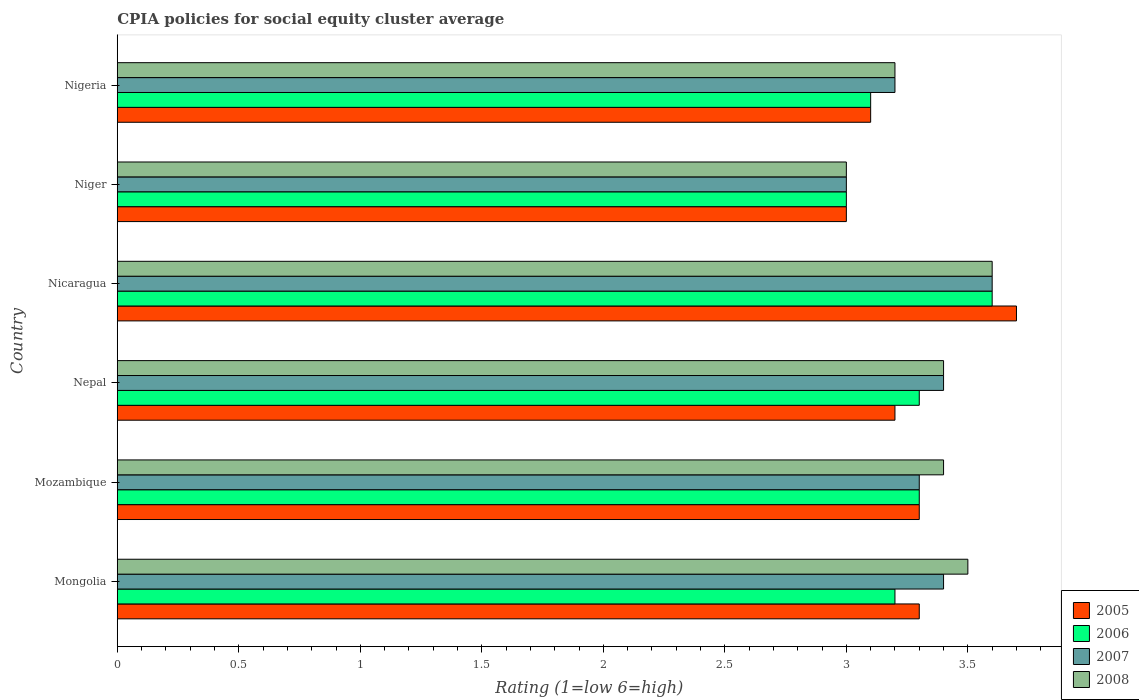How many different coloured bars are there?
Your answer should be compact. 4. Are the number of bars on each tick of the Y-axis equal?
Your response must be concise. Yes. How many bars are there on the 5th tick from the top?
Provide a succinct answer. 4. How many bars are there on the 6th tick from the bottom?
Ensure brevity in your answer.  4. What is the label of the 5th group of bars from the top?
Your answer should be compact. Mozambique. In which country was the CPIA rating in 2006 maximum?
Your answer should be very brief. Nicaragua. In which country was the CPIA rating in 2007 minimum?
Make the answer very short. Niger. What is the difference between the CPIA rating in 2008 in Mongolia and that in Nigeria?
Make the answer very short. 0.3. What is the difference between the CPIA rating in 2005 in Niger and the CPIA rating in 2006 in Nicaragua?
Your answer should be compact. -0.6. What is the average CPIA rating in 2005 per country?
Make the answer very short. 3.27. What is the difference between the CPIA rating in 2005 and CPIA rating in 2007 in Nigeria?
Give a very brief answer. -0.1. Is the CPIA rating in 2007 in Nepal less than that in Niger?
Make the answer very short. No. What is the difference between the highest and the second highest CPIA rating in 2005?
Offer a terse response. 0.4. What is the difference between the highest and the lowest CPIA rating in 2006?
Your answer should be very brief. 0.6. In how many countries, is the CPIA rating in 2006 greater than the average CPIA rating in 2006 taken over all countries?
Give a very brief answer. 3. Is the sum of the CPIA rating in 2006 in Mongolia and Nepal greater than the maximum CPIA rating in 2005 across all countries?
Make the answer very short. Yes. Is it the case that in every country, the sum of the CPIA rating in 2006 and CPIA rating in 2007 is greater than the sum of CPIA rating in 2005 and CPIA rating in 2008?
Your answer should be very brief. No. What is the difference between two consecutive major ticks on the X-axis?
Make the answer very short. 0.5. Are the values on the major ticks of X-axis written in scientific E-notation?
Give a very brief answer. No. What is the title of the graph?
Keep it short and to the point. CPIA policies for social equity cluster average. Does "1961" appear as one of the legend labels in the graph?
Give a very brief answer. No. What is the label or title of the X-axis?
Offer a terse response. Rating (1=low 6=high). What is the Rating (1=low 6=high) of 2006 in Mongolia?
Ensure brevity in your answer.  3.2. What is the Rating (1=low 6=high) in 2008 in Mongolia?
Offer a very short reply. 3.5. What is the Rating (1=low 6=high) of 2005 in Mozambique?
Provide a short and direct response. 3.3. What is the Rating (1=low 6=high) of 2007 in Nepal?
Offer a terse response. 3.4. What is the Rating (1=low 6=high) in 2005 in Nicaragua?
Give a very brief answer. 3.7. What is the Rating (1=low 6=high) in 2007 in Niger?
Provide a short and direct response. 3. What is the Rating (1=low 6=high) in 2005 in Nigeria?
Provide a succinct answer. 3.1. What is the Rating (1=low 6=high) of 2006 in Nigeria?
Provide a short and direct response. 3.1. What is the Rating (1=low 6=high) in 2007 in Nigeria?
Provide a succinct answer. 3.2. Across all countries, what is the maximum Rating (1=low 6=high) in 2006?
Give a very brief answer. 3.6. Across all countries, what is the minimum Rating (1=low 6=high) in 2008?
Ensure brevity in your answer.  3. What is the total Rating (1=low 6=high) of 2005 in the graph?
Your response must be concise. 19.6. What is the total Rating (1=low 6=high) of 2008 in the graph?
Your response must be concise. 20.1. What is the difference between the Rating (1=low 6=high) in 2005 in Mongolia and that in Mozambique?
Provide a succinct answer. 0. What is the difference between the Rating (1=low 6=high) of 2006 in Mongolia and that in Mozambique?
Your answer should be very brief. -0.1. What is the difference between the Rating (1=low 6=high) in 2007 in Mongolia and that in Mozambique?
Offer a terse response. 0.1. What is the difference between the Rating (1=low 6=high) in 2008 in Mongolia and that in Mozambique?
Provide a succinct answer. 0.1. What is the difference between the Rating (1=low 6=high) in 2005 in Mongolia and that in Nepal?
Give a very brief answer. 0.1. What is the difference between the Rating (1=low 6=high) in 2008 in Mongolia and that in Nepal?
Give a very brief answer. 0.1. What is the difference between the Rating (1=low 6=high) of 2006 in Mongolia and that in Nicaragua?
Keep it short and to the point. -0.4. What is the difference between the Rating (1=low 6=high) in 2005 in Mongolia and that in Niger?
Provide a short and direct response. 0.3. What is the difference between the Rating (1=low 6=high) in 2007 in Mongolia and that in Niger?
Make the answer very short. 0.4. What is the difference between the Rating (1=low 6=high) in 2008 in Mongolia and that in Nigeria?
Offer a terse response. 0.3. What is the difference between the Rating (1=low 6=high) of 2005 in Mozambique and that in Nepal?
Make the answer very short. 0.1. What is the difference between the Rating (1=low 6=high) of 2005 in Mozambique and that in Nicaragua?
Offer a very short reply. -0.4. What is the difference between the Rating (1=low 6=high) in 2007 in Mozambique and that in Nicaragua?
Provide a short and direct response. -0.3. What is the difference between the Rating (1=low 6=high) of 2005 in Mozambique and that in Niger?
Your answer should be compact. 0.3. What is the difference between the Rating (1=low 6=high) of 2006 in Mozambique and that in Niger?
Your answer should be compact. 0.3. What is the difference between the Rating (1=low 6=high) in 2008 in Mozambique and that in Niger?
Your answer should be compact. 0.4. What is the difference between the Rating (1=low 6=high) in 2006 in Mozambique and that in Nigeria?
Provide a short and direct response. 0.2. What is the difference between the Rating (1=low 6=high) of 2008 in Mozambique and that in Nigeria?
Your answer should be very brief. 0.2. What is the difference between the Rating (1=low 6=high) of 2007 in Nepal and that in Nicaragua?
Offer a very short reply. -0.2. What is the difference between the Rating (1=low 6=high) in 2008 in Nepal and that in Nicaragua?
Give a very brief answer. -0.2. What is the difference between the Rating (1=low 6=high) of 2005 in Nepal and that in Niger?
Ensure brevity in your answer.  0.2. What is the difference between the Rating (1=low 6=high) in 2007 in Nepal and that in Niger?
Provide a short and direct response. 0.4. What is the difference between the Rating (1=low 6=high) of 2005 in Nepal and that in Nigeria?
Provide a succinct answer. 0.1. What is the difference between the Rating (1=low 6=high) of 2006 in Nepal and that in Nigeria?
Your answer should be compact. 0.2. What is the difference between the Rating (1=low 6=high) in 2007 in Nepal and that in Nigeria?
Your answer should be very brief. 0.2. What is the difference between the Rating (1=low 6=high) of 2008 in Nepal and that in Nigeria?
Offer a terse response. 0.2. What is the difference between the Rating (1=low 6=high) of 2005 in Nicaragua and that in Niger?
Ensure brevity in your answer.  0.7. What is the difference between the Rating (1=low 6=high) in 2007 in Nicaragua and that in Niger?
Make the answer very short. 0.6. What is the difference between the Rating (1=low 6=high) of 2008 in Nicaragua and that in Niger?
Give a very brief answer. 0.6. What is the difference between the Rating (1=low 6=high) of 2005 in Mongolia and the Rating (1=low 6=high) of 2007 in Mozambique?
Offer a terse response. 0. What is the difference between the Rating (1=low 6=high) of 2007 in Mongolia and the Rating (1=low 6=high) of 2008 in Mozambique?
Give a very brief answer. 0. What is the difference between the Rating (1=low 6=high) of 2005 in Mongolia and the Rating (1=low 6=high) of 2007 in Nepal?
Your answer should be compact. -0.1. What is the difference between the Rating (1=low 6=high) of 2005 in Mongolia and the Rating (1=low 6=high) of 2008 in Nepal?
Your answer should be compact. -0.1. What is the difference between the Rating (1=low 6=high) in 2006 in Mongolia and the Rating (1=low 6=high) in 2007 in Nepal?
Ensure brevity in your answer.  -0.2. What is the difference between the Rating (1=low 6=high) of 2006 in Mongolia and the Rating (1=low 6=high) of 2008 in Nepal?
Offer a very short reply. -0.2. What is the difference between the Rating (1=low 6=high) of 2006 in Mongolia and the Rating (1=low 6=high) of 2007 in Nicaragua?
Make the answer very short. -0.4. What is the difference between the Rating (1=low 6=high) of 2006 in Mongolia and the Rating (1=low 6=high) of 2008 in Nicaragua?
Your answer should be very brief. -0.4. What is the difference between the Rating (1=low 6=high) of 2005 in Mongolia and the Rating (1=low 6=high) of 2008 in Niger?
Your answer should be compact. 0.3. What is the difference between the Rating (1=low 6=high) in 2006 in Mongolia and the Rating (1=low 6=high) in 2007 in Niger?
Ensure brevity in your answer.  0.2. What is the difference between the Rating (1=low 6=high) in 2007 in Mongolia and the Rating (1=low 6=high) in 2008 in Niger?
Your answer should be very brief. 0.4. What is the difference between the Rating (1=low 6=high) in 2005 in Mongolia and the Rating (1=low 6=high) in 2006 in Nigeria?
Make the answer very short. 0.2. What is the difference between the Rating (1=low 6=high) of 2006 in Mongolia and the Rating (1=low 6=high) of 2008 in Nigeria?
Provide a short and direct response. 0. What is the difference between the Rating (1=low 6=high) in 2007 in Mongolia and the Rating (1=low 6=high) in 2008 in Nigeria?
Ensure brevity in your answer.  0.2. What is the difference between the Rating (1=low 6=high) of 2005 in Mozambique and the Rating (1=low 6=high) of 2006 in Nepal?
Give a very brief answer. 0. What is the difference between the Rating (1=low 6=high) of 2005 in Mozambique and the Rating (1=low 6=high) of 2007 in Nepal?
Ensure brevity in your answer.  -0.1. What is the difference between the Rating (1=low 6=high) in 2007 in Mozambique and the Rating (1=low 6=high) in 2008 in Nepal?
Provide a short and direct response. -0.1. What is the difference between the Rating (1=low 6=high) in 2005 in Mozambique and the Rating (1=low 6=high) in 2007 in Nicaragua?
Give a very brief answer. -0.3. What is the difference between the Rating (1=low 6=high) in 2007 in Mozambique and the Rating (1=low 6=high) in 2008 in Nicaragua?
Your answer should be very brief. -0.3. What is the difference between the Rating (1=low 6=high) of 2005 in Mozambique and the Rating (1=low 6=high) of 2006 in Niger?
Offer a very short reply. 0.3. What is the difference between the Rating (1=low 6=high) of 2005 in Mozambique and the Rating (1=low 6=high) of 2007 in Niger?
Make the answer very short. 0.3. What is the difference between the Rating (1=low 6=high) of 2006 in Mozambique and the Rating (1=low 6=high) of 2008 in Niger?
Provide a succinct answer. 0.3. What is the difference between the Rating (1=low 6=high) of 2007 in Mozambique and the Rating (1=low 6=high) of 2008 in Niger?
Ensure brevity in your answer.  0.3. What is the difference between the Rating (1=low 6=high) of 2005 in Mozambique and the Rating (1=low 6=high) of 2006 in Nigeria?
Make the answer very short. 0.2. What is the difference between the Rating (1=low 6=high) of 2005 in Mozambique and the Rating (1=low 6=high) of 2007 in Nigeria?
Make the answer very short. 0.1. What is the difference between the Rating (1=low 6=high) in 2006 in Mozambique and the Rating (1=low 6=high) in 2007 in Nigeria?
Give a very brief answer. 0.1. What is the difference between the Rating (1=low 6=high) in 2006 in Nepal and the Rating (1=low 6=high) in 2007 in Nicaragua?
Your answer should be very brief. -0.3. What is the difference between the Rating (1=low 6=high) in 2006 in Nepal and the Rating (1=low 6=high) in 2008 in Nicaragua?
Offer a very short reply. -0.3. What is the difference between the Rating (1=low 6=high) of 2005 in Nepal and the Rating (1=low 6=high) of 2006 in Niger?
Ensure brevity in your answer.  0.2. What is the difference between the Rating (1=low 6=high) in 2005 in Nepal and the Rating (1=low 6=high) in 2008 in Niger?
Your response must be concise. 0.2. What is the difference between the Rating (1=low 6=high) in 2006 in Nepal and the Rating (1=low 6=high) in 2007 in Niger?
Your answer should be very brief. 0.3. What is the difference between the Rating (1=low 6=high) in 2005 in Nepal and the Rating (1=low 6=high) in 2007 in Nigeria?
Your answer should be compact. 0. What is the difference between the Rating (1=low 6=high) in 2006 in Nepal and the Rating (1=low 6=high) in 2007 in Nigeria?
Your response must be concise. 0.1. What is the difference between the Rating (1=low 6=high) of 2007 in Nepal and the Rating (1=low 6=high) of 2008 in Nigeria?
Offer a terse response. 0.2. What is the difference between the Rating (1=low 6=high) in 2005 in Nicaragua and the Rating (1=low 6=high) in 2008 in Niger?
Offer a terse response. 0.7. What is the difference between the Rating (1=low 6=high) in 2006 in Nicaragua and the Rating (1=low 6=high) in 2007 in Niger?
Keep it short and to the point. 0.6. What is the difference between the Rating (1=low 6=high) in 2005 in Nicaragua and the Rating (1=low 6=high) in 2008 in Nigeria?
Provide a succinct answer. 0.5. What is the difference between the Rating (1=low 6=high) in 2006 in Nicaragua and the Rating (1=low 6=high) in 2007 in Nigeria?
Provide a short and direct response. 0.4. What is the difference between the Rating (1=low 6=high) in 2007 in Nicaragua and the Rating (1=low 6=high) in 2008 in Nigeria?
Ensure brevity in your answer.  0.4. What is the difference between the Rating (1=low 6=high) in 2005 in Niger and the Rating (1=low 6=high) in 2006 in Nigeria?
Provide a succinct answer. -0.1. What is the difference between the Rating (1=low 6=high) in 2006 in Niger and the Rating (1=low 6=high) in 2007 in Nigeria?
Provide a succinct answer. -0.2. What is the difference between the Rating (1=low 6=high) of 2006 in Niger and the Rating (1=low 6=high) of 2008 in Nigeria?
Your answer should be very brief. -0.2. What is the average Rating (1=low 6=high) of 2005 per country?
Offer a very short reply. 3.27. What is the average Rating (1=low 6=high) of 2006 per country?
Your answer should be very brief. 3.25. What is the average Rating (1=low 6=high) in 2007 per country?
Keep it short and to the point. 3.32. What is the average Rating (1=low 6=high) of 2008 per country?
Make the answer very short. 3.35. What is the difference between the Rating (1=low 6=high) in 2005 and Rating (1=low 6=high) in 2007 in Mongolia?
Provide a short and direct response. -0.1. What is the difference between the Rating (1=low 6=high) of 2005 and Rating (1=low 6=high) of 2008 in Mongolia?
Offer a terse response. -0.2. What is the difference between the Rating (1=low 6=high) of 2006 and Rating (1=low 6=high) of 2007 in Mongolia?
Provide a short and direct response. -0.2. What is the difference between the Rating (1=low 6=high) of 2006 and Rating (1=low 6=high) of 2008 in Mongolia?
Your answer should be very brief. -0.3. What is the difference between the Rating (1=low 6=high) in 2005 and Rating (1=low 6=high) in 2008 in Mozambique?
Your answer should be very brief. -0.1. What is the difference between the Rating (1=low 6=high) of 2006 and Rating (1=low 6=high) of 2007 in Mozambique?
Your response must be concise. 0. What is the difference between the Rating (1=low 6=high) of 2006 and Rating (1=low 6=high) of 2008 in Mozambique?
Ensure brevity in your answer.  -0.1. What is the difference between the Rating (1=low 6=high) in 2007 and Rating (1=low 6=high) in 2008 in Mozambique?
Offer a very short reply. -0.1. What is the difference between the Rating (1=low 6=high) in 2005 and Rating (1=low 6=high) in 2006 in Nepal?
Ensure brevity in your answer.  -0.1. What is the difference between the Rating (1=low 6=high) of 2005 and Rating (1=low 6=high) of 2007 in Nepal?
Provide a succinct answer. -0.2. What is the difference between the Rating (1=low 6=high) in 2006 and Rating (1=low 6=high) in 2008 in Nepal?
Provide a short and direct response. -0.1. What is the difference between the Rating (1=low 6=high) of 2006 and Rating (1=low 6=high) of 2007 in Nicaragua?
Give a very brief answer. 0. What is the difference between the Rating (1=low 6=high) of 2006 and Rating (1=low 6=high) of 2008 in Nicaragua?
Keep it short and to the point. 0. What is the difference between the Rating (1=low 6=high) of 2005 and Rating (1=low 6=high) of 2006 in Niger?
Keep it short and to the point. 0. What is the difference between the Rating (1=low 6=high) in 2005 and Rating (1=low 6=high) in 2008 in Niger?
Your response must be concise. 0. What is the difference between the Rating (1=low 6=high) in 2007 and Rating (1=low 6=high) in 2008 in Niger?
Your response must be concise. 0. What is the difference between the Rating (1=low 6=high) in 2005 and Rating (1=low 6=high) in 2007 in Nigeria?
Your answer should be very brief. -0.1. What is the difference between the Rating (1=low 6=high) in 2006 and Rating (1=low 6=high) in 2008 in Nigeria?
Your response must be concise. -0.1. What is the difference between the Rating (1=low 6=high) in 2007 and Rating (1=low 6=high) in 2008 in Nigeria?
Make the answer very short. 0. What is the ratio of the Rating (1=low 6=high) in 2006 in Mongolia to that in Mozambique?
Your answer should be compact. 0.97. What is the ratio of the Rating (1=low 6=high) in 2007 in Mongolia to that in Mozambique?
Make the answer very short. 1.03. What is the ratio of the Rating (1=low 6=high) in 2008 in Mongolia to that in Mozambique?
Provide a succinct answer. 1.03. What is the ratio of the Rating (1=low 6=high) of 2005 in Mongolia to that in Nepal?
Your answer should be very brief. 1.03. What is the ratio of the Rating (1=low 6=high) in 2006 in Mongolia to that in Nepal?
Your answer should be very brief. 0.97. What is the ratio of the Rating (1=low 6=high) in 2008 in Mongolia to that in Nepal?
Provide a succinct answer. 1.03. What is the ratio of the Rating (1=low 6=high) in 2005 in Mongolia to that in Nicaragua?
Make the answer very short. 0.89. What is the ratio of the Rating (1=low 6=high) of 2006 in Mongolia to that in Nicaragua?
Offer a very short reply. 0.89. What is the ratio of the Rating (1=low 6=high) in 2008 in Mongolia to that in Nicaragua?
Offer a very short reply. 0.97. What is the ratio of the Rating (1=low 6=high) in 2006 in Mongolia to that in Niger?
Offer a terse response. 1.07. What is the ratio of the Rating (1=low 6=high) in 2007 in Mongolia to that in Niger?
Provide a succinct answer. 1.13. What is the ratio of the Rating (1=low 6=high) of 2008 in Mongolia to that in Niger?
Offer a very short reply. 1.17. What is the ratio of the Rating (1=low 6=high) of 2005 in Mongolia to that in Nigeria?
Offer a terse response. 1.06. What is the ratio of the Rating (1=low 6=high) in 2006 in Mongolia to that in Nigeria?
Make the answer very short. 1.03. What is the ratio of the Rating (1=low 6=high) of 2008 in Mongolia to that in Nigeria?
Provide a succinct answer. 1.09. What is the ratio of the Rating (1=low 6=high) in 2005 in Mozambique to that in Nepal?
Offer a terse response. 1.03. What is the ratio of the Rating (1=low 6=high) of 2007 in Mozambique to that in Nepal?
Your answer should be very brief. 0.97. What is the ratio of the Rating (1=low 6=high) of 2005 in Mozambique to that in Nicaragua?
Your answer should be very brief. 0.89. What is the ratio of the Rating (1=low 6=high) of 2006 in Mozambique to that in Nicaragua?
Provide a short and direct response. 0.92. What is the ratio of the Rating (1=low 6=high) in 2007 in Mozambique to that in Nicaragua?
Give a very brief answer. 0.92. What is the ratio of the Rating (1=low 6=high) in 2008 in Mozambique to that in Nicaragua?
Make the answer very short. 0.94. What is the ratio of the Rating (1=low 6=high) of 2007 in Mozambique to that in Niger?
Keep it short and to the point. 1.1. What is the ratio of the Rating (1=low 6=high) of 2008 in Mozambique to that in Niger?
Offer a terse response. 1.13. What is the ratio of the Rating (1=low 6=high) in 2005 in Mozambique to that in Nigeria?
Ensure brevity in your answer.  1.06. What is the ratio of the Rating (1=low 6=high) in 2006 in Mozambique to that in Nigeria?
Your answer should be compact. 1.06. What is the ratio of the Rating (1=low 6=high) in 2007 in Mozambique to that in Nigeria?
Your answer should be compact. 1.03. What is the ratio of the Rating (1=low 6=high) of 2005 in Nepal to that in Nicaragua?
Your response must be concise. 0.86. What is the ratio of the Rating (1=low 6=high) of 2007 in Nepal to that in Nicaragua?
Your answer should be compact. 0.94. What is the ratio of the Rating (1=low 6=high) of 2005 in Nepal to that in Niger?
Offer a very short reply. 1.07. What is the ratio of the Rating (1=low 6=high) of 2006 in Nepal to that in Niger?
Keep it short and to the point. 1.1. What is the ratio of the Rating (1=low 6=high) in 2007 in Nepal to that in Niger?
Your answer should be very brief. 1.13. What is the ratio of the Rating (1=low 6=high) in 2008 in Nepal to that in Niger?
Your answer should be very brief. 1.13. What is the ratio of the Rating (1=low 6=high) in 2005 in Nepal to that in Nigeria?
Provide a short and direct response. 1.03. What is the ratio of the Rating (1=low 6=high) of 2006 in Nepal to that in Nigeria?
Provide a succinct answer. 1.06. What is the ratio of the Rating (1=low 6=high) of 2007 in Nepal to that in Nigeria?
Provide a short and direct response. 1.06. What is the ratio of the Rating (1=low 6=high) in 2005 in Nicaragua to that in Niger?
Your response must be concise. 1.23. What is the ratio of the Rating (1=low 6=high) in 2008 in Nicaragua to that in Niger?
Keep it short and to the point. 1.2. What is the ratio of the Rating (1=low 6=high) in 2005 in Nicaragua to that in Nigeria?
Offer a very short reply. 1.19. What is the ratio of the Rating (1=low 6=high) of 2006 in Nicaragua to that in Nigeria?
Provide a succinct answer. 1.16. What is the ratio of the Rating (1=low 6=high) in 2007 in Nicaragua to that in Nigeria?
Offer a very short reply. 1.12. What is the ratio of the Rating (1=low 6=high) of 2005 in Niger to that in Nigeria?
Offer a terse response. 0.97. What is the ratio of the Rating (1=low 6=high) in 2008 in Niger to that in Nigeria?
Provide a short and direct response. 0.94. What is the difference between the highest and the second highest Rating (1=low 6=high) of 2005?
Provide a short and direct response. 0.4. What is the difference between the highest and the second highest Rating (1=low 6=high) in 2007?
Your answer should be very brief. 0.2. What is the difference between the highest and the lowest Rating (1=low 6=high) of 2006?
Give a very brief answer. 0.6. What is the difference between the highest and the lowest Rating (1=low 6=high) in 2007?
Keep it short and to the point. 0.6. 